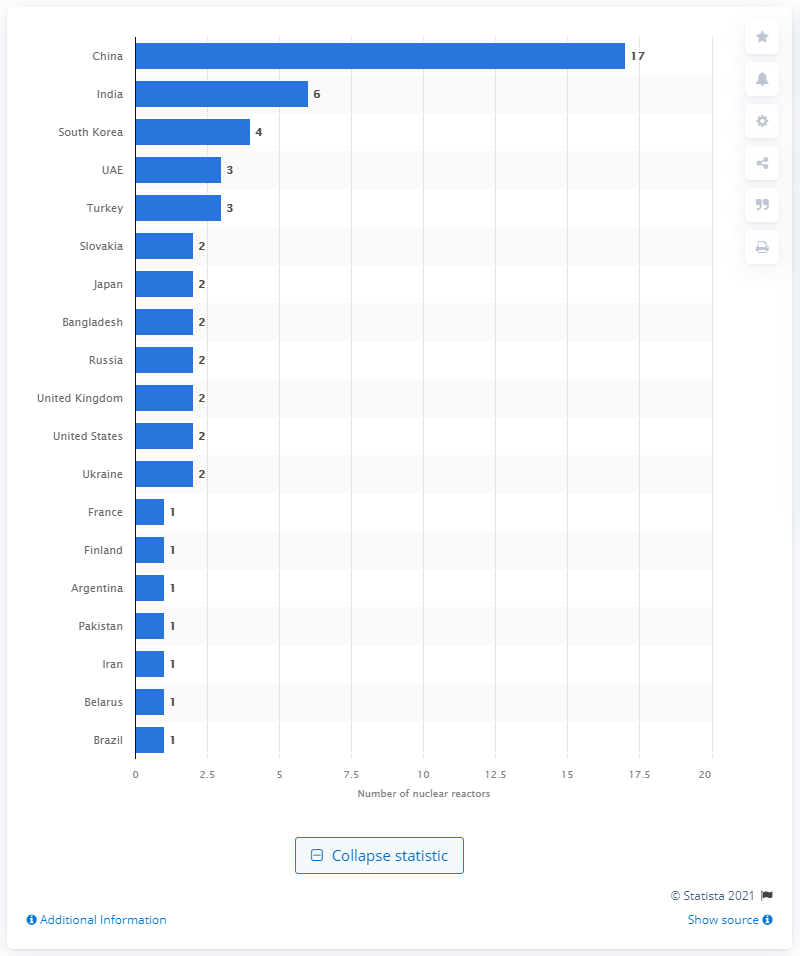Indicate a few pertinent items in this graphic. The Bushehr Nuclear Power Plant is located in Iran. 